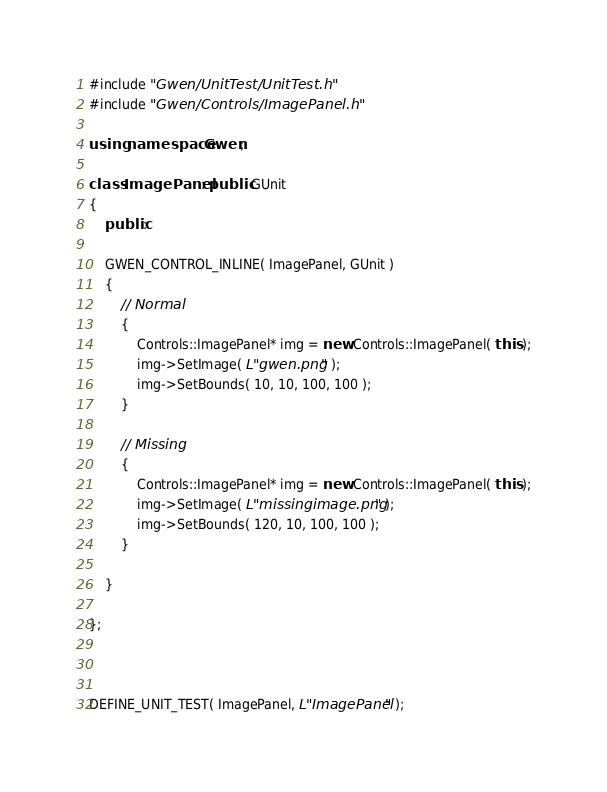Convert code to text. <code><loc_0><loc_0><loc_500><loc_500><_C++_>#include "Gwen/UnitTest/UnitTest.h"
#include "Gwen/Controls/ImagePanel.h"

using namespace Gwen;

class ImagePanel : public GUnit
{
	public:

	GWEN_CONTROL_INLINE( ImagePanel, GUnit )
	{
		// Normal
		{
			Controls::ImagePanel* img = new Controls::ImagePanel( this );
			img->SetImage( L"gwen.png" );
			img->SetBounds( 10, 10, 100, 100 );
		}

		// Missing
		{
			Controls::ImagePanel* img = new Controls::ImagePanel( this );
			img->SetImage( L"missingimage.png" );
			img->SetBounds( 120, 10, 100, 100 );
		}

	}

};



DEFINE_UNIT_TEST( ImagePanel, L"ImagePanel" );</code> 